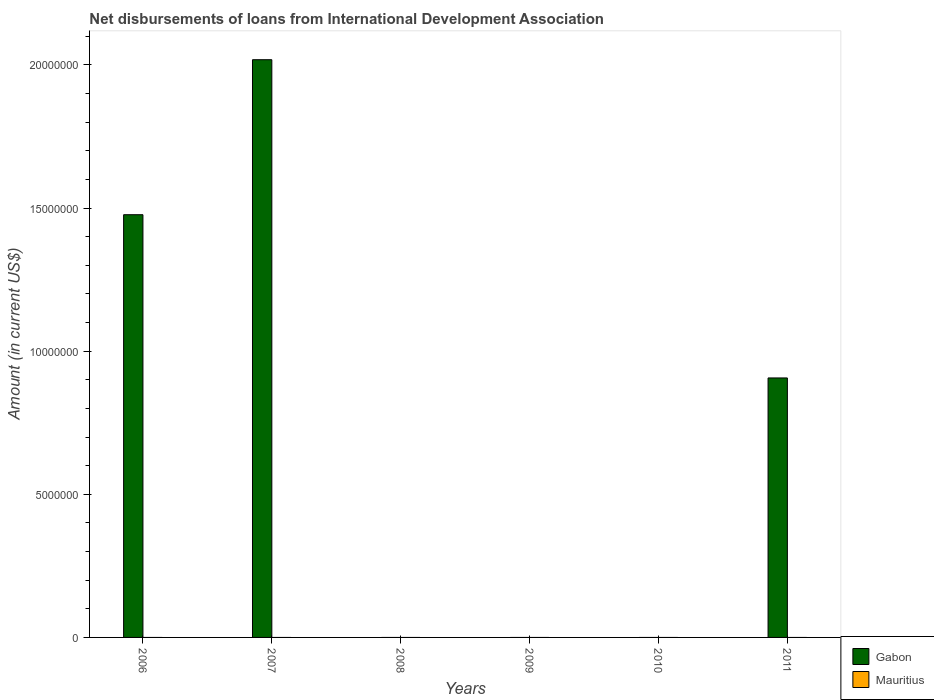How many different coloured bars are there?
Keep it short and to the point. 1. How many bars are there on the 3rd tick from the right?
Your answer should be compact. 0. What is the label of the 2nd group of bars from the left?
Give a very brief answer. 2007. What is the amount of loans disbursed in Mauritius in 2011?
Your answer should be very brief. 0. Across all years, what is the maximum amount of loans disbursed in Gabon?
Offer a terse response. 2.02e+07. Across all years, what is the minimum amount of loans disbursed in Gabon?
Make the answer very short. 0. In which year was the amount of loans disbursed in Gabon maximum?
Your answer should be compact. 2007. What is the total amount of loans disbursed in Gabon in the graph?
Your answer should be very brief. 4.40e+07. What is the difference between the amount of loans disbursed in Gabon in 2006 and that in 2011?
Give a very brief answer. 5.70e+06. What is the average amount of loans disbursed in Gabon per year?
Offer a terse response. 7.34e+06. In how many years, is the amount of loans disbursed in Mauritius greater than 5000000 US$?
Provide a succinct answer. 0. What is the ratio of the amount of loans disbursed in Gabon in 2007 to that in 2011?
Offer a terse response. 2.23. What is the difference between the highest and the second highest amount of loans disbursed in Gabon?
Make the answer very short. 5.41e+06. What is the difference between the highest and the lowest amount of loans disbursed in Gabon?
Offer a very short reply. 2.02e+07. In how many years, is the amount of loans disbursed in Mauritius greater than the average amount of loans disbursed in Mauritius taken over all years?
Provide a short and direct response. 0. Are all the bars in the graph horizontal?
Your answer should be compact. No. Are the values on the major ticks of Y-axis written in scientific E-notation?
Your answer should be very brief. No. Does the graph contain any zero values?
Provide a short and direct response. Yes. Does the graph contain grids?
Give a very brief answer. No. Where does the legend appear in the graph?
Your answer should be very brief. Bottom right. How many legend labels are there?
Provide a short and direct response. 2. What is the title of the graph?
Offer a very short reply. Net disbursements of loans from International Development Association. Does "Angola" appear as one of the legend labels in the graph?
Your response must be concise. No. What is the label or title of the Y-axis?
Give a very brief answer. Amount (in current US$). What is the Amount (in current US$) in Gabon in 2006?
Ensure brevity in your answer.  1.48e+07. What is the Amount (in current US$) of Mauritius in 2006?
Keep it short and to the point. 0. What is the Amount (in current US$) in Gabon in 2007?
Make the answer very short. 2.02e+07. What is the Amount (in current US$) of Mauritius in 2007?
Keep it short and to the point. 0. What is the Amount (in current US$) of Mauritius in 2010?
Your response must be concise. 0. What is the Amount (in current US$) in Gabon in 2011?
Make the answer very short. 9.06e+06. Across all years, what is the maximum Amount (in current US$) of Gabon?
Give a very brief answer. 2.02e+07. What is the total Amount (in current US$) in Gabon in the graph?
Provide a short and direct response. 4.40e+07. What is the total Amount (in current US$) in Mauritius in the graph?
Your response must be concise. 0. What is the difference between the Amount (in current US$) in Gabon in 2006 and that in 2007?
Provide a short and direct response. -5.41e+06. What is the difference between the Amount (in current US$) of Gabon in 2006 and that in 2011?
Ensure brevity in your answer.  5.70e+06. What is the difference between the Amount (in current US$) of Gabon in 2007 and that in 2011?
Your answer should be compact. 1.11e+07. What is the average Amount (in current US$) of Gabon per year?
Ensure brevity in your answer.  7.34e+06. What is the ratio of the Amount (in current US$) of Gabon in 2006 to that in 2007?
Provide a short and direct response. 0.73. What is the ratio of the Amount (in current US$) in Gabon in 2006 to that in 2011?
Ensure brevity in your answer.  1.63. What is the ratio of the Amount (in current US$) in Gabon in 2007 to that in 2011?
Your answer should be very brief. 2.23. What is the difference between the highest and the second highest Amount (in current US$) in Gabon?
Ensure brevity in your answer.  5.41e+06. What is the difference between the highest and the lowest Amount (in current US$) of Gabon?
Your answer should be compact. 2.02e+07. 